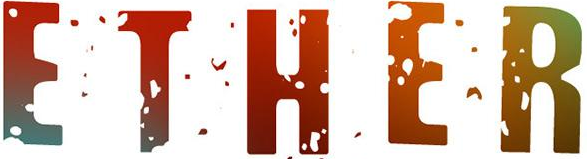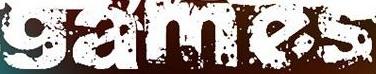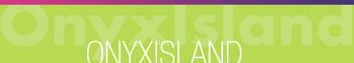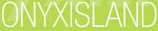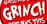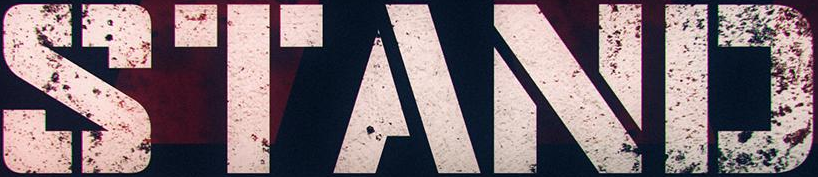Identify the words shown in these images in order, separated by a semicolon. ETHER; games; Onyxlsland; ONYXISLAND; GRINGH; STAND 